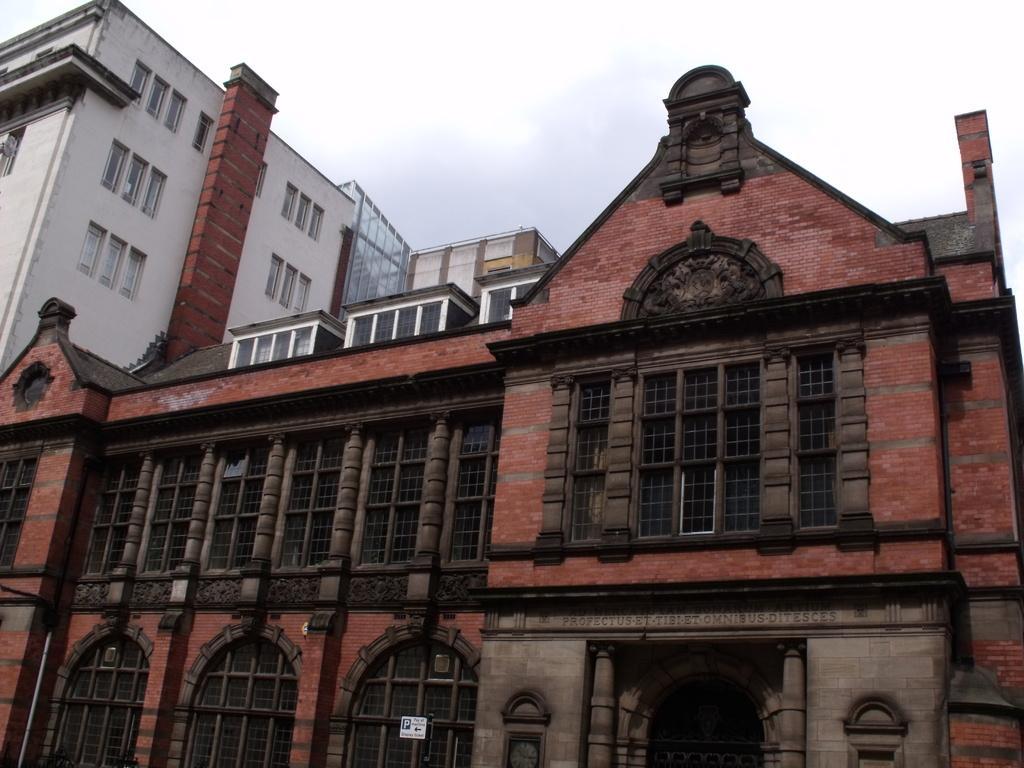Please provide a concise description of this image. In this image I can see a building with red color bricks, at the top of the image I can see the sky. 